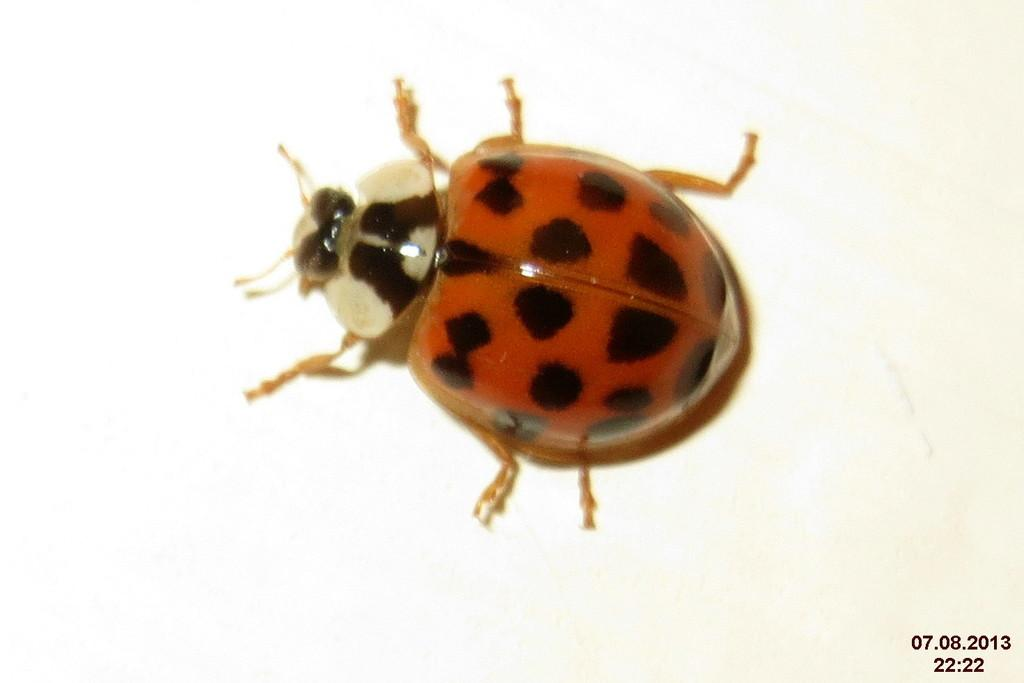What type of creature is in the picture? There is an insect in the picture. What colors can be seen on the insect? The insect has red and black colors. Where is the insect located in the image? The insect is on the floor. What color is the floor in the image? The floor is white in color. What type of shoes can be seen on the insect in the image? There are no shoes present on the insect in the image. Is the insect visible during the night in the image? The time of day is not mentioned in the image, so it cannot be determined if the insect is visible during the night. 